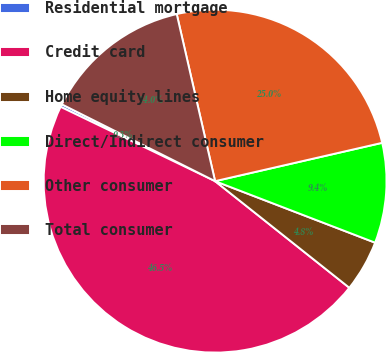<chart> <loc_0><loc_0><loc_500><loc_500><pie_chart><fcel>Residential mortgage<fcel>Credit card<fcel>Home equity lines<fcel>Direct/Indirect consumer<fcel>Other consumer<fcel>Total consumer<nl><fcel>0.26%<fcel>46.45%<fcel>4.84%<fcel>9.43%<fcel>25.0%<fcel>14.01%<nl></chart> 